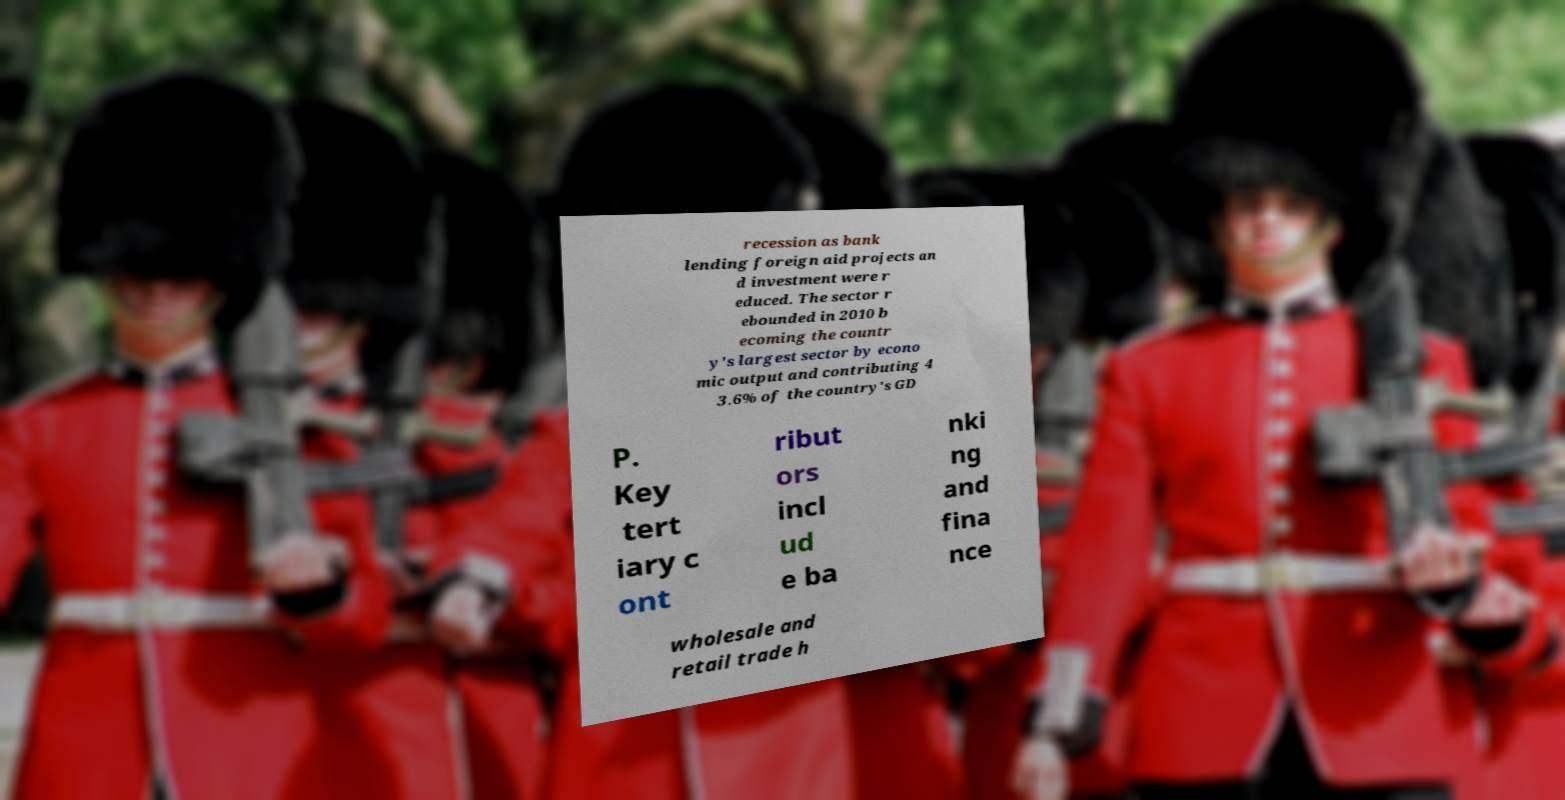Could you assist in decoding the text presented in this image and type it out clearly? recession as bank lending foreign aid projects an d investment were r educed. The sector r ebounded in 2010 b ecoming the countr y's largest sector by econo mic output and contributing 4 3.6% of the country's GD P. Key tert iary c ont ribut ors incl ud e ba nki ng and fina nce wholesale and retail trade h 